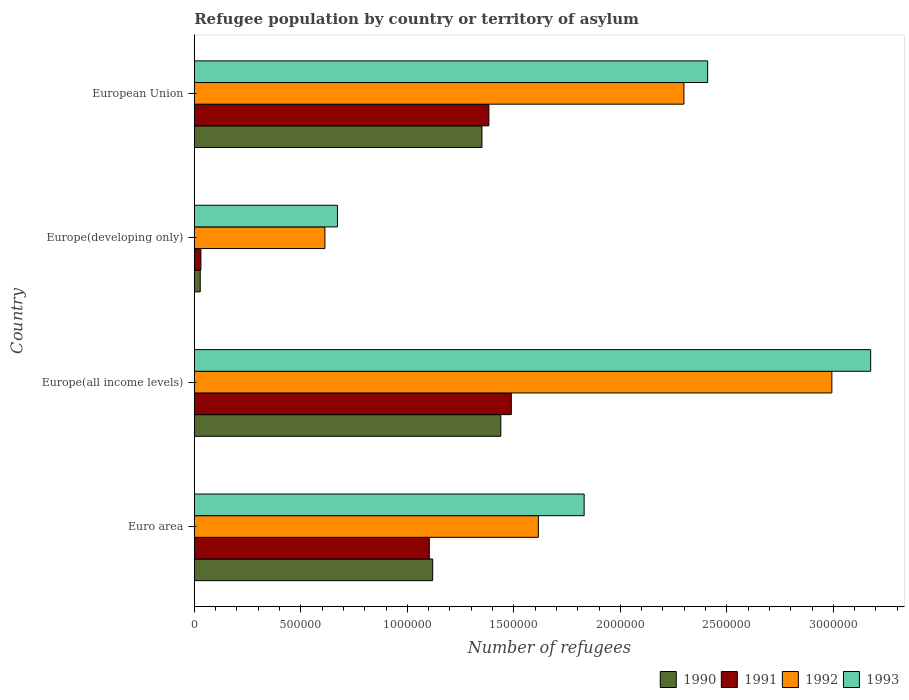How many different coloured bars are there?
Keep it short and to the point. 4. How many groups of bars are there?
Offer a very short reply. 4. Are the number of bars on each tick of the Y-axis equal?
Provide a succinct answer. Yes. How many bars are there on the 3rd tick from the top?
Offer a terse response. 4. What is the label of the 3rd group of bars from the top?
Make the answer very short. Europe(all income levels). In how many cases, is the number of bars for a given country not equal to the number of legend labels?
Offer a very short reply. 0. What is the number of refugees in 1992 in Euro area?
Offer a very short reply. 1.62e+06. Across all countries, what is the maximum number of refugees in 1992?
Give a very brief answer. 2.99e+06. Across all countries, what is the minimum number of refugees in 1991?
Provide a succinct answer. 3.11e+04. In which country was the number of refugees in 1990 maximum?
Keep it short and to the point. Europe(all income levels). In which country was the number of refugees in 1990 minimum?
Your answer should be compact. Europe(developing only). What is the total number of refugees in 1993 in the graph?
Offer a terse response. 8.09e+06. What is the difference between the number of refugees in 1991 in Europe(developing only) and that in European Union?
Make the answer very short. -1.35e+06. What is the difference between the number of refugees in 1990 in Euro area and the number of refugees in 1993 in Europe(developing only)?
Keep it short and to the point. 4.47e+05. What is the average number of refugees in 1991 per country?
Make the answer very short. 1.00e+06. What is the difference between the number of refugees in 1993 and number of refugees in 1992 in Europe(all income levels)?
Make the answer very short. 1.82e+05. What is the ratio of the number of refugees in 1993 in Euro area to that in Europe(all income levels)?
Your answer should be very brief. 0.58. Is the difference between the number of refugees in 1993 in Europe(all income levels) and European Union greater than the difference between the number of refugees in 1992 in Europe(all income levels) and European Union?
Provide a succinct answer. Yes. What is the difference between the highest and the second highest number of refugees in 1990?
Provide a short and direct response. 8.86e+04. What is the difference between the highest and the lowest number of refugees in 1993?
Make the answer very short. 2.50e+06. In how many countries, is the number of refugees in 1992 greater than the average number of refugees in 1992 taken over all countries?
Keep it short and to the point. 2. Is the sum of the number of refugees in 1991 in Europe(all income levels) and European Union greater than the maximum number of refugees in 1990 across all countries?
Provide a short and direct response. Yes. How many countries are there in the graph?
Offer a terse response. 4. Does the graph contain grids?
Keep it short and to the point. No. Where does the legend appear in the graph?
Give a very brief answer. Bottom right. What is the title of the graph?
Offer a terse response. Refugee population by country or territory of asylum. Does "2000" appear as one of the legend labels in the graph?
Provide a succinct answer. No. What is the label or title of the X-axis?
Your answer should be very brief. Number of refugees. What is the label or title of the Y-axis?
Offer a very short reply. Country. What is the Number of refugees of 1990 in Euro area?
Keep it short and to the point. 1.12e+06. What is the Number of refugees of 1991 in Euro area?
Your answer should be compact. 1.10e+06. What is the Number of refugees in 1992 in Euro area?
Your answer should be compact. 1.62e+06. What is the Number of refugees in 1993 in Euro area?
Make the answer very short. 1.83e+06. What is the Number of refugees of 1990 in Europe(all income levels)?
Offer a terse response. 1.44e+06. What is the Number of refugees in 1991 in Europe(all income levels)?
Offer a very short reply. 1.49e+06. What is the Number of refugees of 1992 in Europe(all income levels)?
Offer a very short reply. 2.99e+06. What is the Number of refugees in 1993 in Europe(all income levels)?
Your response must be concise. 3.18e+06. What is the Number of refugees in 1990 in Europe(developing only)?
Offer a terse response. 2.80e+04. What is the Number of refugees in 1991 in Europe(developing only)?
Offer a very short reply. 3.11e+04. What is the Number of refugees in 1992 in Europe(developing only)?
Your response must be concise. 6.13e+05. What is the Number of refugees of 1993 in Europe(developing only)?
Provide a succinct answer. 6.72e+05. What is the Number of refugees of 1990 in European Union?
Keep it short and to the point. 1.35e+06. What is the Number of refugees of 1991 in European Union?
Provide a succinct answer. 1.38e+06. What is the Number of refugees of 1992 in European Union?
Make the answer very short. 2.30e+06. What is the Number of refugees in 1993 in European Union?
Your answer should be compact. 2.41e+06. Across all countries, what is the maximum Number of refugees of 1990?
Offer a terse response. 1.44e+06. Across all countries, what is the maximum Number of refugees of 1991?
Offer a terse response. 1.49e+06. Across all countries, what is the maximum Number of refugees of 1992?
Your answer should be compact. 2.99e+06. Across all countries, what is the maximum Number of refugees of 1993?
Offer a terse response. 3.18e+06. Across all countries, what is the minimum Number of refugees in 1990?
Offer a terse response. 2.80e+04. Across all countries, what is the minimum Number of refugees in 1991?
Provide a short and direct response. 3.11e+04. Across all countries, what is the minimum Number of refugees of 1992?
Offer a very short reply. 6.13e+05. Across all countries, what is the minimum Number of refugees of 1993?
Make the answer very short. 6.72e+05. What is the total Number of refugees in 1990 in the graph?
Ensure brevity in your answer.  3.94e+06. What is the total Number of refugees of 1991 in the graph?
Offer a terse response. 4.01e+06. What is the total Number of refugees of 1992 in the graph?
Offer a terse response. 7.52e+06. What is the total Number of refugees of 1993 in the graph?
Your answer should be compact. 8.09e+06. What is the difference between the Number of refugees of 1990 in Euro area and that in Europe(all income levels)?
Make the answer very short. -3.20e+05. What is the difference between the Number of refugees of 1991 in Euro area and that in Europe(all income levels)?
Your answer should be very brief. -3.85e+05. What is the difference between the Number of refugees of 1992 in Euro area and that in Europe(all income levels)?
Offer a terse response. -1.38e+06. What is the difference between the Number of refugees of 1993 in Euro area and that in Europe(all income levels)?
Give a very brief answer. -1.34e+06. What is the difference between the Number of refugees of 1990 in Euro area and that in Europe(developing only)?
Your answer should be compact. 1.09e+06. What is the difference between the Number of refugees in 1991 in Euro area and that in Europe(developing only)?
Give a very brief answer. 1.07e+06. What is the difference between the Number of refugees of 1992 in Euro area and that in Europe(developing only)?
Offer a very short reply. 1.00e+06. What is the difference between the Number of refugees in 1993 in Euro area and that in Europe(developing only)?
Make the answer very short. 1.16e+06. What is the difference between the Number of refugees of 1990 in Euro area and that in European Union?
Make the answer very short. -2.31e+05. What is the difference between the Number of refugees in 1991 in Euro area and that in European Union?
Offer a very short reply. -2.80e+05. What is the difference between the Number of refugees in 1992 in Euro area and that in European Union?
Offer a terse response. -6.83e+05. What is the difference between the Number of refugees in 1993 in Euro area and that in European Union?
Your response must be concise. -5.80e+05. What is the difference between the Number of refugees of 1990 in Europe(all income levels) and that in Europe(developing only)?
Give a very brief answer. 1.41e+06. What is the difference between the Number of refugees in 1991 in Europe(all income levels) and that in Europe(developing only)?
Your response must be concise. 1.46e+06. What is the difference between the Number of refugees in 1992 in Europe(all income levels) and that in Europe(developing only)?
Keep it short and to the point. 2.38e+06. What is the difference between the Number of refugees of 1993 in Europe(all income levels) and that in Europe(developing only)?
Ensure brevity in your answer.  2.50e+06. What is the difference between the Number of refugees of 1990 in Europe(all income levels) and that in European Union?
Give a very brief answer. 8.86e+04. What is the difference between the Number of refugees in 1991 in Europe(all income levels) and that in European Union?
Provide a short and direct response. 1.05e+05. What is the difference between the Number of refugees of 1992 in Europe(all income levels) and that in European Union?
Make the answer very short. 6.94e+05. What is the difference between the Number of refugees of 1993 in Europe(all income levels) and that in European Union?
Your response must be concise. 7.65e+05. What is the difference between the Number of refugees of 1990 in Europe(developing only) and that in European Union?
Ensure brevity in your answer.  -1.32e+06. What is the difference between the Number of refugees of 1991 in Europe(developing only) and that in European Union?
Give a very brief answer. -1.35e+06. What is the difference between the Number of refugees in 1992 in Europe(developing only) and that in European Union?
Provide a succinct answer. -1.69e+06. What is the difference between the Number of refugees of 1993 in Europe(developing only) and that in European Union?
Keep it short and to the point. -1.74e+06. What is the difference between the Number of refugees of 1990 in Euro area and the Number of refugees of 1991 in Europe(all income levels)?
Make the answer very short. -3.69e+05. What is the difference between the Number of refugees of 1990 in Euro area and the Number of refugees of 1992 in Europe(all income levels)?
Keep it short and to the point. -1.87e+06. What is the difference between the Number of refugees in 1990 in Euro area and the Number of refugees in 1993 in Europe(all income levels)?
Make the answer very short. -2.06e+06. What is the difference between the Number of refugees in 1991 in Euro area and the Number of refugees in 1992 in Europe(all income levels)?
Provide a succinct answer. -1.89e+06. What is the difference between the Number of refugees of 1991 in Euro area and the Number of refugees of 1993 in Europe(all income levels)?
Your answer should be compact. -2.07e+06. What is the difference between the Number of refugees in 1992 in Euro area and the Number of refugees in 1993 in Europe(all income levels)?
Your answer should be very brief. -1.56e+06. What is the difference between the Number of refugees in 1990 in Euro area and the Number of refugees in 1991 in Europe(developing only)?
Provide a succinct answer. 1.09e+06. What is the difference between the Number of refugees in 1990 in Euro area and the Number of refugees in 1992 in Europe(developing only)?
Ensure brevity in your answer.  5.06e+05. What is the difference between the Number of refugees of 1990 in Euro area and the Number of refugees of 1993 in Europe(developing only)?
Offer a very short reply. 4.47e+05. What is the difference between the Number of refugees in 1991 in Euro area and the Number of refugees in 1992 in Europe(developing only)?
Your answer should be very brief. 4.90e+05. What is the difference between the Number of refugees in 1991 in Euro area and the Number of refugees in 1993 in Europe(developing only)?
Offer a terse response. 4.31e+05. What is the difference between the Number of refugees of 1992 in Euro area and the Number of refugees of 1993 in Europe(developing only)?
Keep it short and to the point. 9.43e+05. What is the difference between the Number of refugees in 1990 in Euro area and the Number of refugees in 1991 in European Union?
Offer a very short reply. -2.64e+05. What is the difference between the Number of refugees of 1990 in Euro area and the Number of refugees of 1992 in European Union?
Your answer should be very brief. -1.18e+06. What is the difference between the Number of refugees in 1990 in Euro area and the Number of refugees in 1993 in European Union?
Your answer should be compact. -1.29e+06. What is the difference between the Number of refugees in 1991 in Euro area and the Number of refugees in 1992 in European Union?
Give a very brief answer. -1.20e+06. What is the difference between the Number of refugees of 1991 in Euro area and the Number of refugees of 1993 in European Union?
Provide a short and direct response. -1.31e+06. What is the difference between the Number of refugees in 1992 in Euro area and the Number of refugees in 1993 in European Union?
Give a very brief answer. -7.95e+05. What is the difference between the Number of refugees in 1990 in Europe(all income levels) and the Number of refugees in 1991 in Europe(developing only)?
Your answer should be compact. 1.41e+06. What is the difference between the Number of refugees in 1990 in Europe(all income levels) and the Number of refugees in 1992 in Europe(developing only)?
Offer a terse response. 8.26e+05. What is the difference between the Number of refugees of 1990 in Europe(all income levels) and the Number of refugees of 1993 in Europe(developing only)?
Keep it short and to the point. 7.67e+05. What is the difference between the Number of refugees in 1991 in Europe(all income levels) and the Number of refugees in 1992 in Europe(developing only)?
Provide a short and direct response. 8.75e+05. What is the difference between the Number of refugees in 1991 in Europe(all income levels) and the Number of refugees in 1993 in Europe(developing only)?
Provide a short and direct response. 8.16e+05. What is the difference between the Number of refugees of 1992 in Europe(all income levels) and the Number of refugees of 1993 in Europe(developing only)?
Your answer should be very brief. 2.32e+06. What is the difference between the Number of refugees in 1990 in Europe(all income levels) and the Number of refugees in 1991 in European Union?
Your answer should be very brief. 5.61e+04. What is the difference between the Number of refugees of 1990 in Europe(all income levels) and the Number of refugees of 1992 in European Union?
Make the answer very short. -8.59e+05. What is the difference between the Number of refugees in 1990 in Europe(all income levels) and the Number of refugees in 1993 in European Union?
Keep it short and to the point. -9.71e+05. What is the difference between the Number of refugees of 1991 in Europe(all income levels) and the Number of refugees of 1992 in European Union?
Provide a succinct answer. -8.10e+05. What is the difference between the Number of refugees in 1991 in Europe(all income levels) and the Number of refugees in 1993 in European Union?
Ensure brevity in your answer.  -9.22e+05. What is the difference between the Number of refugees of 1992 in Europe(all income levels) and the Number of refugees of 1993 in European Union?
Offer a very short reply. 5.83e+05. What is the difference between the Number of refugees of 1990 in Europe(developing only) and the Number of refugees of 1991 in European Union?
Give a very brief answer. -1.35e+06. What is the difference between the Number of refugees of 1990 in Europe(developing only) and the Number of refugees of 1992 in European Union?
Ensure brevity in your answer.  -2.27e+06. What is the difference between the Number of refugees of 1990 in Europe(developing only) and the Number of refugees of 1993 in European Union?
Offer a terse response. -2.38e+06. What is the difference between the Number of refugees of 1991 in Europe(developing only) and the Number of refugees of 1992 in European Union?
Offer a very short reply. -2.27e+06. What is the difference between the Number of refugees in 1991 in Europe(developing only) and the Number of refugees in 1993 in European Union?
Your answer should be compact. -2.38e+06. What is the difference between the Number of refugees in 1992 in Europe(developing only) and the Number of refugees in 1993 in European Union?
Make the answer very short. -1.80e+06. What is the average Number of refugees in 1990 per country?
Ensure brevity in your answer.  9.84e+05. What is the average Number of refugees of 1991 per country?
Keep it short and to the point. 1.00e+06. What is the average Number of refugees in 1992 per country?
Offer a very short reply. 1.88e+06. What is the average Number of refugees in 1993 per country?
Give a very brief answer. 2.02e+06. What is the difference between the Number of refugees of 1990 and Number of refugees of 1991 in Euro area?
Give a very brief answer. 1.58e+04. What is the difference between the Number of refugees in 1990 and Number of refugees in 1992 in Euro area?
Your answer should be very brief. -4.96e+05. What is the difference between the Number of refugees in 1990 and Number of refugees in 1993 in Euro area?
Provide a short and direct response. -7.11e+05. What is the difference between the Number of refugees in 1991 and Number of refugees in 1992 in Euro area?
Make the answer very short. -5.12e+05. What is the difference between the Number of refugees of 1991 and Number of refugees of 1993 in Euro area?
Ensure brevity in your answer.  -7.27e+05. What is the difference between the Number of refugees of 1992 and Number of refugees of 1993 in Euro area?
Provide a short and direct response. -2.15e+05. What is the difference between the Number of refugees of 1990 and Number of refugees of 1991 in Europe(all income levels)?
Your answer should be compact. -4.92e+04. What is the difference between the Number of refugees of 1990 and Number of refugees of 1992 in Europe(all income levels)?
Offer a very short reply. -1.55e+06. What is the difference between the Number of refugees of 1990 and Number of refugees of 1993 in Europe(all income levels)?
Provide a short and direct response. -1.74e+06. What is the difference between the Number of refugees in 1991 and Number of refugees in 1992 in Europe(all income levels)?
Give a very brief answer. -1.50e+06. What is the difference between the Number of refugees of 1991 and Number of refugees of 1993 in Europe(all income levels)?
Give a very brief answer. -1.69e+06. What is the difference between the Number of refugees in 1992 and Number of refugees in 1993 in Europe(all income levels)?
Keep it short and to the point. -1.82e+05. What is the difference between the Number of refugees in 1990 and Number of refugees in 1991 in Europe(developing only)?
Provide a succinct answer. -3113. What is the difference between the Number of refugees in 1990 and Number of refugees in 1992 in Europe(developing only)?
Ensure brevity in your answer.  -5.85e+05. What is the difference between the Number of refugees of 1990 and Number of refugees of 1993 in Europe(developing only)?
Make the answer very short. -6.44e+05. What is the difference between the Number of refugees of 1991 and Number of refugees of 1992 in Europe(developing only)?
Keep it short and to the point. -5.82e+05. What is the difference between the Number of refugees of 1991 and Number of refugees of 1993 in Europe(developing only)?
Your answer should be compact. -6.41e+05. What is the difference between the Number of refugees in 1992 and Number of refugees in 1993 in Europe(developing only)?
Your answer should be very brief. -5.89e+04. What is the difference between the Number of refugees of 1990 and Number of refugees of 1991 in European Union?
Your answer should be very brief. -3.25e+04. What is the difference between the Number of refugees in 1990 and Number of refugees in 1992 in European Union?
Provide a succinct answer. -9.48e+05. What is the difference between the Number of refugees of 1990 and Number of refugees of 1993 in European Union?
Offer a very short reply. -1.06e+06. What is the difference between the Number of refugees in 1991 and Number of refugees in 1992 in European Union?
Offer a very short reply. -9.15e+05. What is the difference between the Number of refugees in 1991 and Number of refugees in 1993 in European Union?
Ensure brevity in your answer.  -1.03e+06. What is the difference between the Number of refugees in 1992 and Number of refugees in 1993 in European Union?
Offer a very short reply. -1.11e+05. What is the ratio of the Number of refugees in 1990 in Euro area to that in Europe(all income levels)?
Provide a short and direct response. 0.78. What is the ratio of the Number of refugees in 1991 in Euro area to that in Europe(all income levels)?
Make the answer very short. 0.74. What is the ratio of the Number of refugees in 1992 in Euro area to that in Europe(all income levels)?
Your answer should be very brief. 0.54. What is the ratio of the Number of refugees in 1993 in Euro area to that in Europe(all income levels)?
Give a very brief answer. 0.58. What is the ratio of the Number of refugees in 1990 in Euro area to that in Europe(developing only)?
Your answer should be compact. 39.97. What is the ratio of the Number of refugees in 1991 in Euro area to that in Europe(developing only)?
Provide a short and direct response. 35.46. What is the ratio of the Number of refugees of 1992 in Euro area to that in Europe(developing only)?
Give a very brief answer. 2.63. What is the ratio of the Number of refugees in 1993 in Euro area to that in Europe(developing only)?
Keep it short and to the point. 2.72. What is the ratio of the Number of refugees of 1990 in Euro area to that in European Union?
Keep it short and to the point. 0.83. What is the ratio of the Number of refugees in 1991 in Euro area to that in European Union?
Your answer should be very brief. 0.8. What is the ratio of the Number of refugees of 1992 in Euro area to that in European Union?
Provide a short and direct response. 0.7. What is the ratio of the Number of refugees in 1993 in Euro area to that in European Union?
Your response must be concise. 0.76. What is the ratio of the Number of refugees in 1990 in Europe(all income levels) to that in Europe(developing only)?
Ensure brevity in your answer.  51.39. What is the ratio of the Number of refugees in 1991 in Europe(all income levels) to that in Europe(developing only)?
Your response must be concise. 47.83. What is the ratio of the Number of refugees of 1992 in Europe(all income levels) to that in Europe(developing only)?
Give a very brief answer. 4.88. What is the ratio of the Number of refugees of 1993 in Europe(all income levels) to that in Europe(developing only)?
Your answer should be compact. 4.72. What is the ratio of the Number of refugees of 1990 in Europe(all income levels) to that in European Union?
Make the answer very short. 1.07. What is the ratio of the Number of refugees of 1991 in Europe(all income levels) to that in European Union?
Ensure brevity in your answer.  1.08. What is the ratio of the Number of refugees in 1992 in Europe(all income levels) to that in European Union?
Give a very brief answer. 1.3. What is the ratio of the Number of refugees in 1993 in Europe(all income levels) to that in European Union?
Your answer should be compact. 1.32. What is the ratio of the Number of refugees in 1990 in Europe(developing only) to that in European Union?
Make the answer very short. 0.02. What is the ratio of the Number of refugees in 1991 in Europe(developing only) to that in European Union?
Provide a succinct answer. 0.02. What is the ratio of the Number of refugees of 1992 in Europe(developing only) to that in European Union?
Give a very brief answer. 0.27. What is the ratio of the Number of refugees in 1993 in Europe(developing only) to that in European Union?
Your response must be concise. 0.28. What is the difference between the highest and the second highest Number of refugees of 1990?
Keep it short and to the point. 8.86e+04. What is the difference between the highest and the second highest Number of refugees of 1991?
Your response must be concise. 1.05e+05. What is the difference between the highest and the second highest Number of refugees of 1992?
Keep it short and to the point. 6.94e+05. What is the difference between the highest and the second highest Number of refugees in 1993?
Your answer should be compact. 7.65e+05. What is the difference between the highest and the lowest Number of refugees in 1990?
Offer a terse response. 1.41e+06. What is the difference between the highest and the lowest Number of refugees in 1991?
Your response must be concise. 1.46e+06. What is the difference between the highest and the lowest Number of refugees in 1992?
Keep it short and to the point. 2.38e+06. What is the difference between the highest and the lowest Number of refugees of 1993?
Offer a terse response. 2.50e+06. 